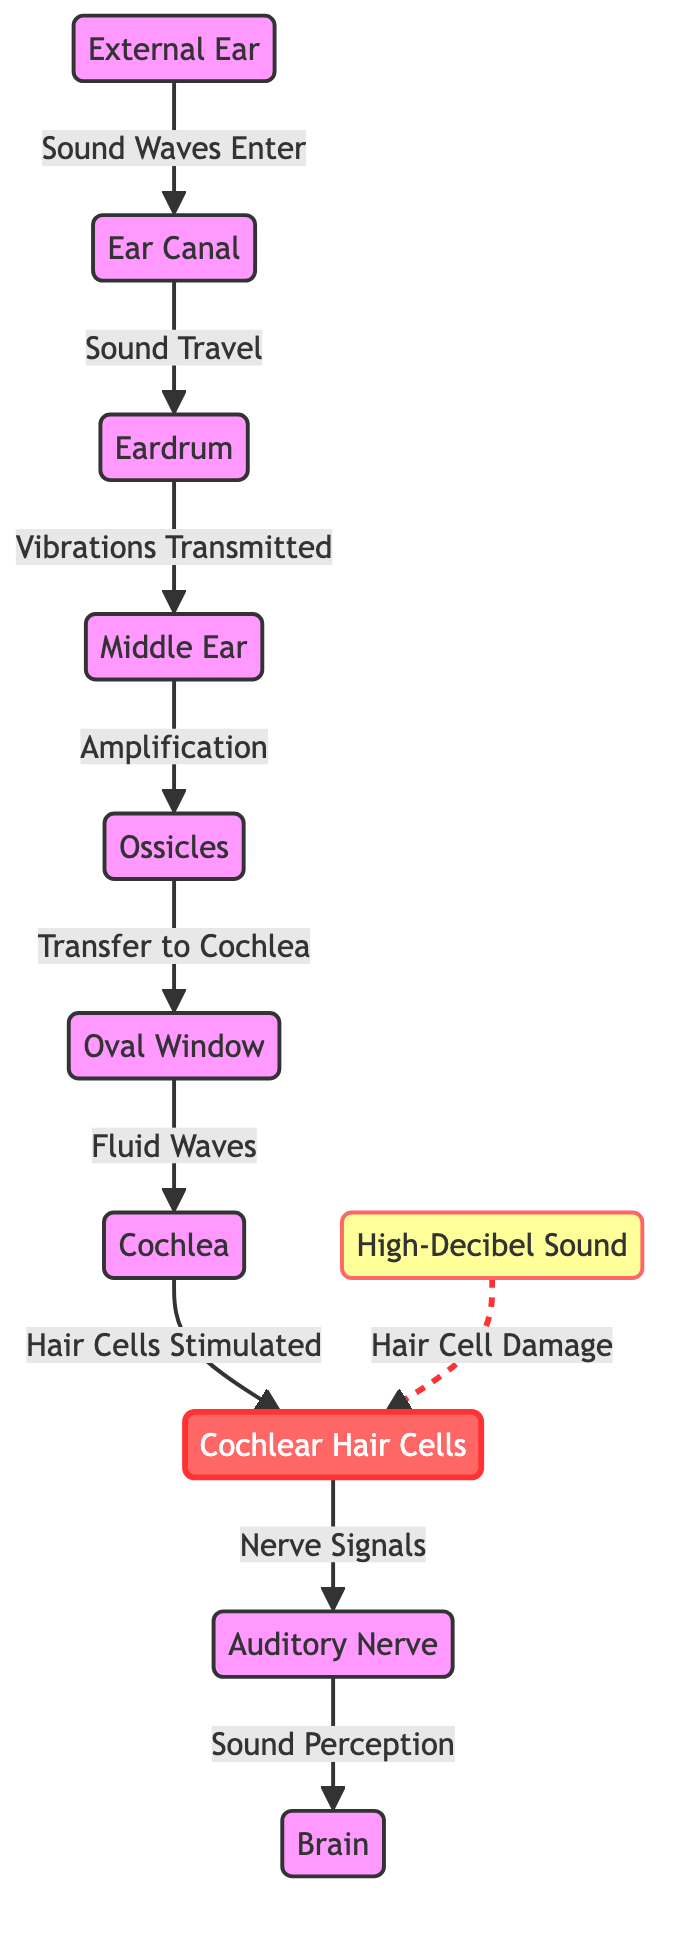What is the first structure sound waves enter? According to the diagram, sound waves enter the external ear first before traveling through the ear canal.
Answer: external ear How many ossicles are there in the middle ear? The diagram does not specify a number for the ossicles, but the typical number of ossicles in the human ear is three (malleus, incus, stapes).
Answer: three What type of sound is indicated to cause damage to hair cells? The diagram shows that high-decibel sound is indicated as having a relationship with causing harm to cochlear hair cells.
Answer: high-decibel sound Which structure follows the oval window in the pathway of sound transmission? The oval window sends fluid waves to the cochlea, making cochlea the next structure in the pathway.
Answer: cochlea What signals are sent to the brain from the cochlear hair cells? The cochlear hair cells generate nerve signals that are sent to the auditory nerve, which then transmits these signals to the brain.
Answer: nerve signals What is one effect of high-decibel sound on cochlear hair cells? High-decibel sound is indicated to cause hair cell damage, which means the hair cells may be adversely affected by exposure to loud noises.
Answer: hair cell damage What kind of waves enter the cochlea? Fluid waves are indicated to travel into the cochlea, as shown in the diagram.
Answer: fluid waves Which structure is directly responsible for amplifying sound? The middle ear is responsible for amplifying sound through the action of the ossicles, making it the structure to focus on for sound amplification.
Answer: middle ear What is the final destination of the auditory nerve signals? The auditory nerve transmits its signals to the brain, which acts as the final destination for sound perception.
Answer: brain 